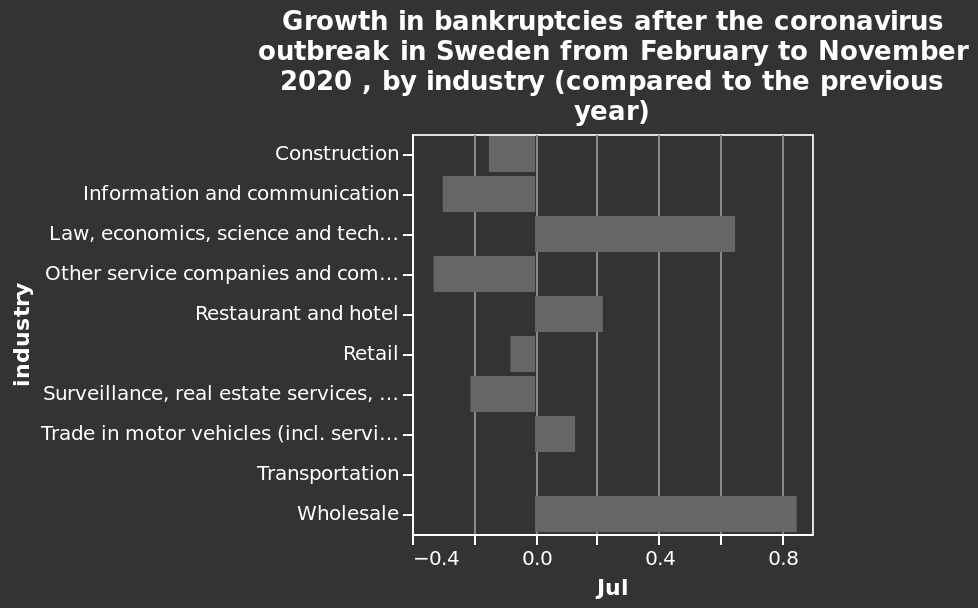<image>
What is the main cause behind the growth in bankruptcy? The coronavirus pandemic. What does the x-axis represent on the bar graph?  The x-axis represents the growth in bankruptcies after the coronavirus outbreak in Sweden from February to November 2020, by industry. What does the y-axis represent on the bar graph?  The y-axis represents different industries, ranging from Construction to Wholesale. What has been the impact of the coronavirus on bankruptcy rates?  The growth in bankruptcy rates has been significant. What is the range of values shown on the x-axis? The x-axis ranges from -0.4 to 0.8 on a categorical scale. 